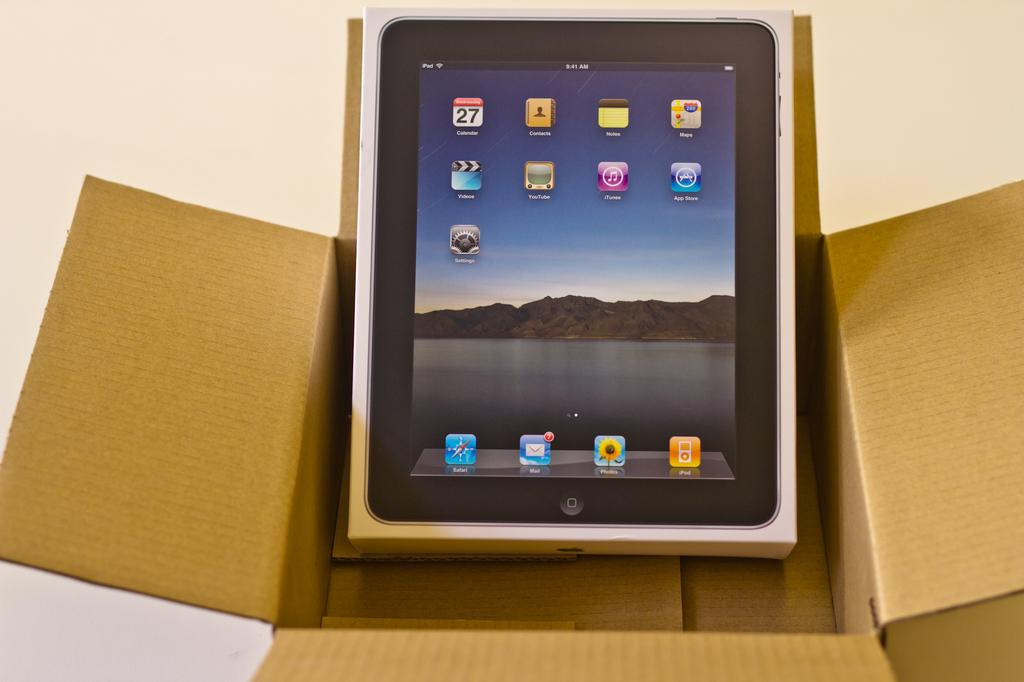What is the main object in the image? There is a box in the image. Can you describe the position of the box in the image? The box is inside another box. What type of railway is visible in the image? There is no railway present in the image; it only features a box inside another box. 